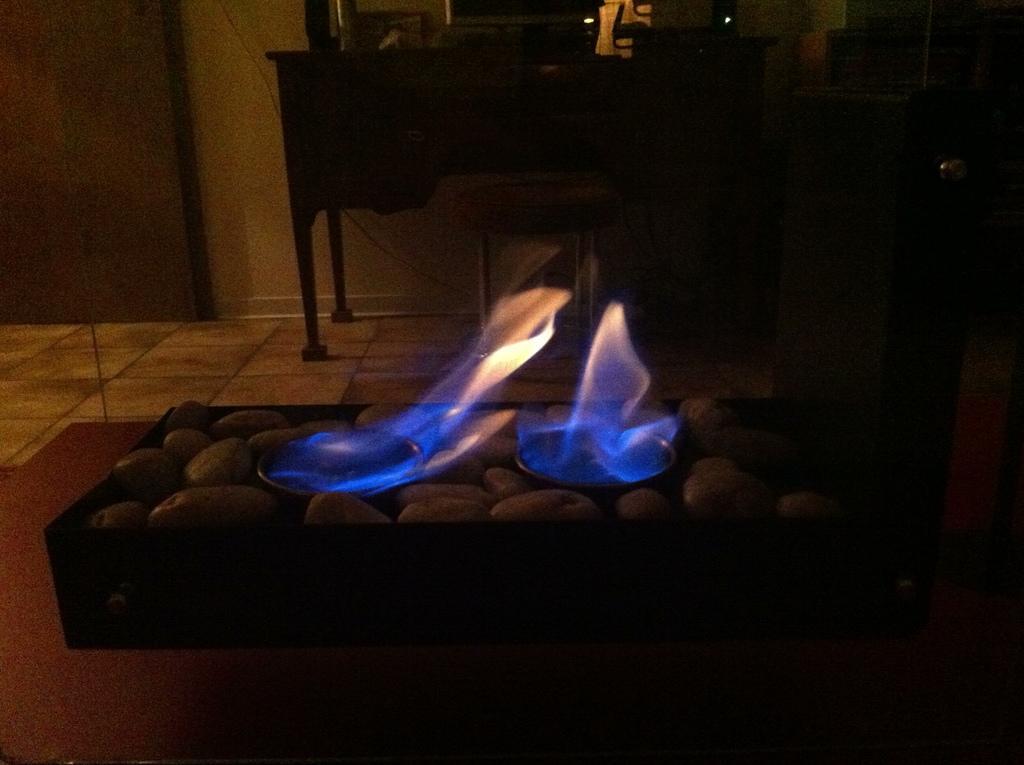Please provide a concise description of this image. In this picture there is an object placed on a table which has few potatoes placed in it and there is fire in between it and there is a table,stool and some other objects in the background. 